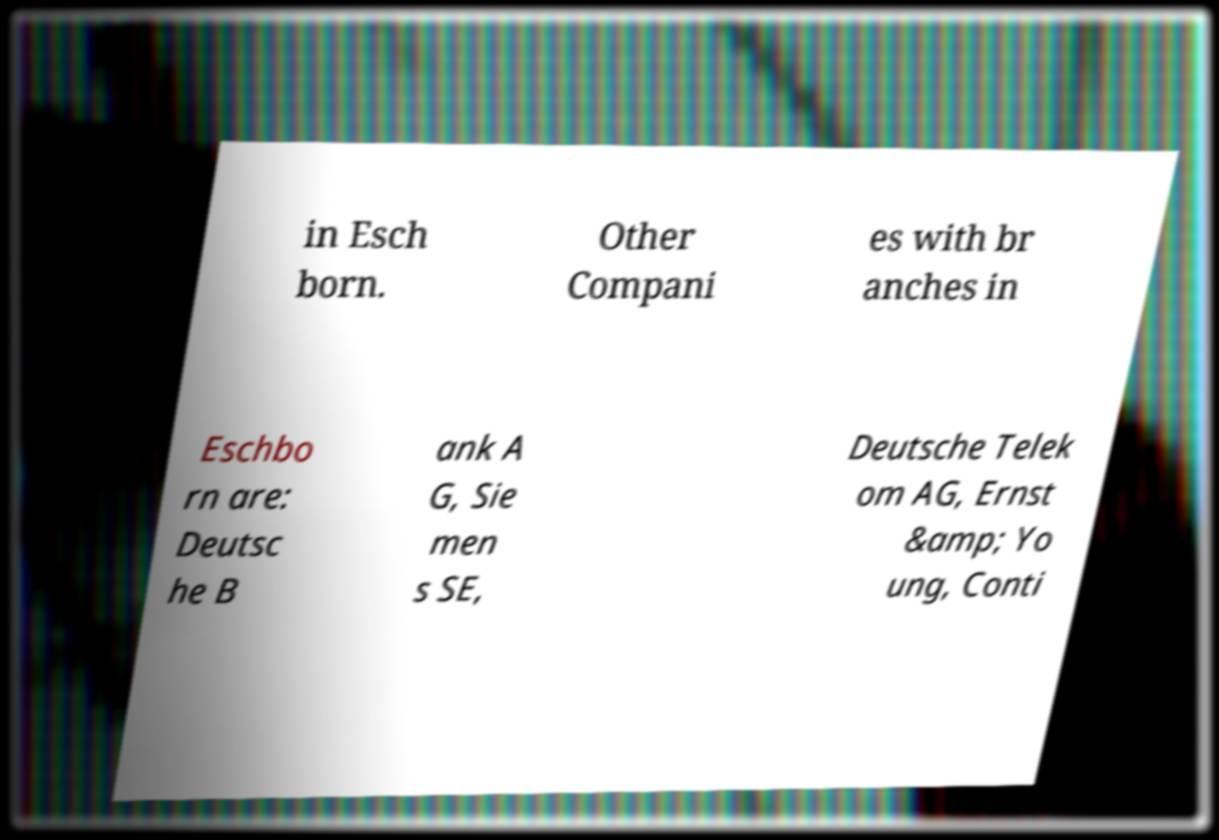Could you assist in decoding the text presented in this image and type it out clearly? in Esch born. Other Compani es with br anches in Eschbo rn are: Deutsc he B ank A G, Sie men s SE, Deutsche Telek om AG, Ernst &amp; Yo ung, Conti 